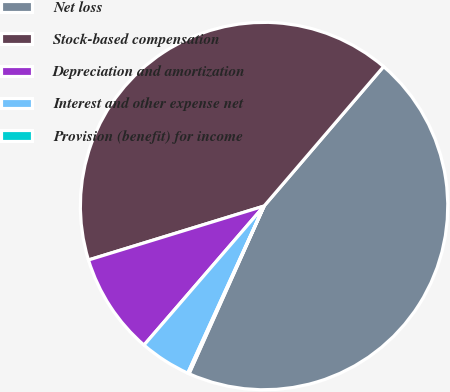<chart> <loc_0><loc_0><loc_500><loc_500><pie_chart><fcel>Net loss<fcel>Stock-based compensation<fcel>Depreciation and amortization<fcel>Interest and other expense net<fcel>Provision (benefit) for income<nl><fcel>45.42%<fcel>41.02%<fcel>8.92%<fcel>4.52%<fcel>0.12%<nl></chart> 